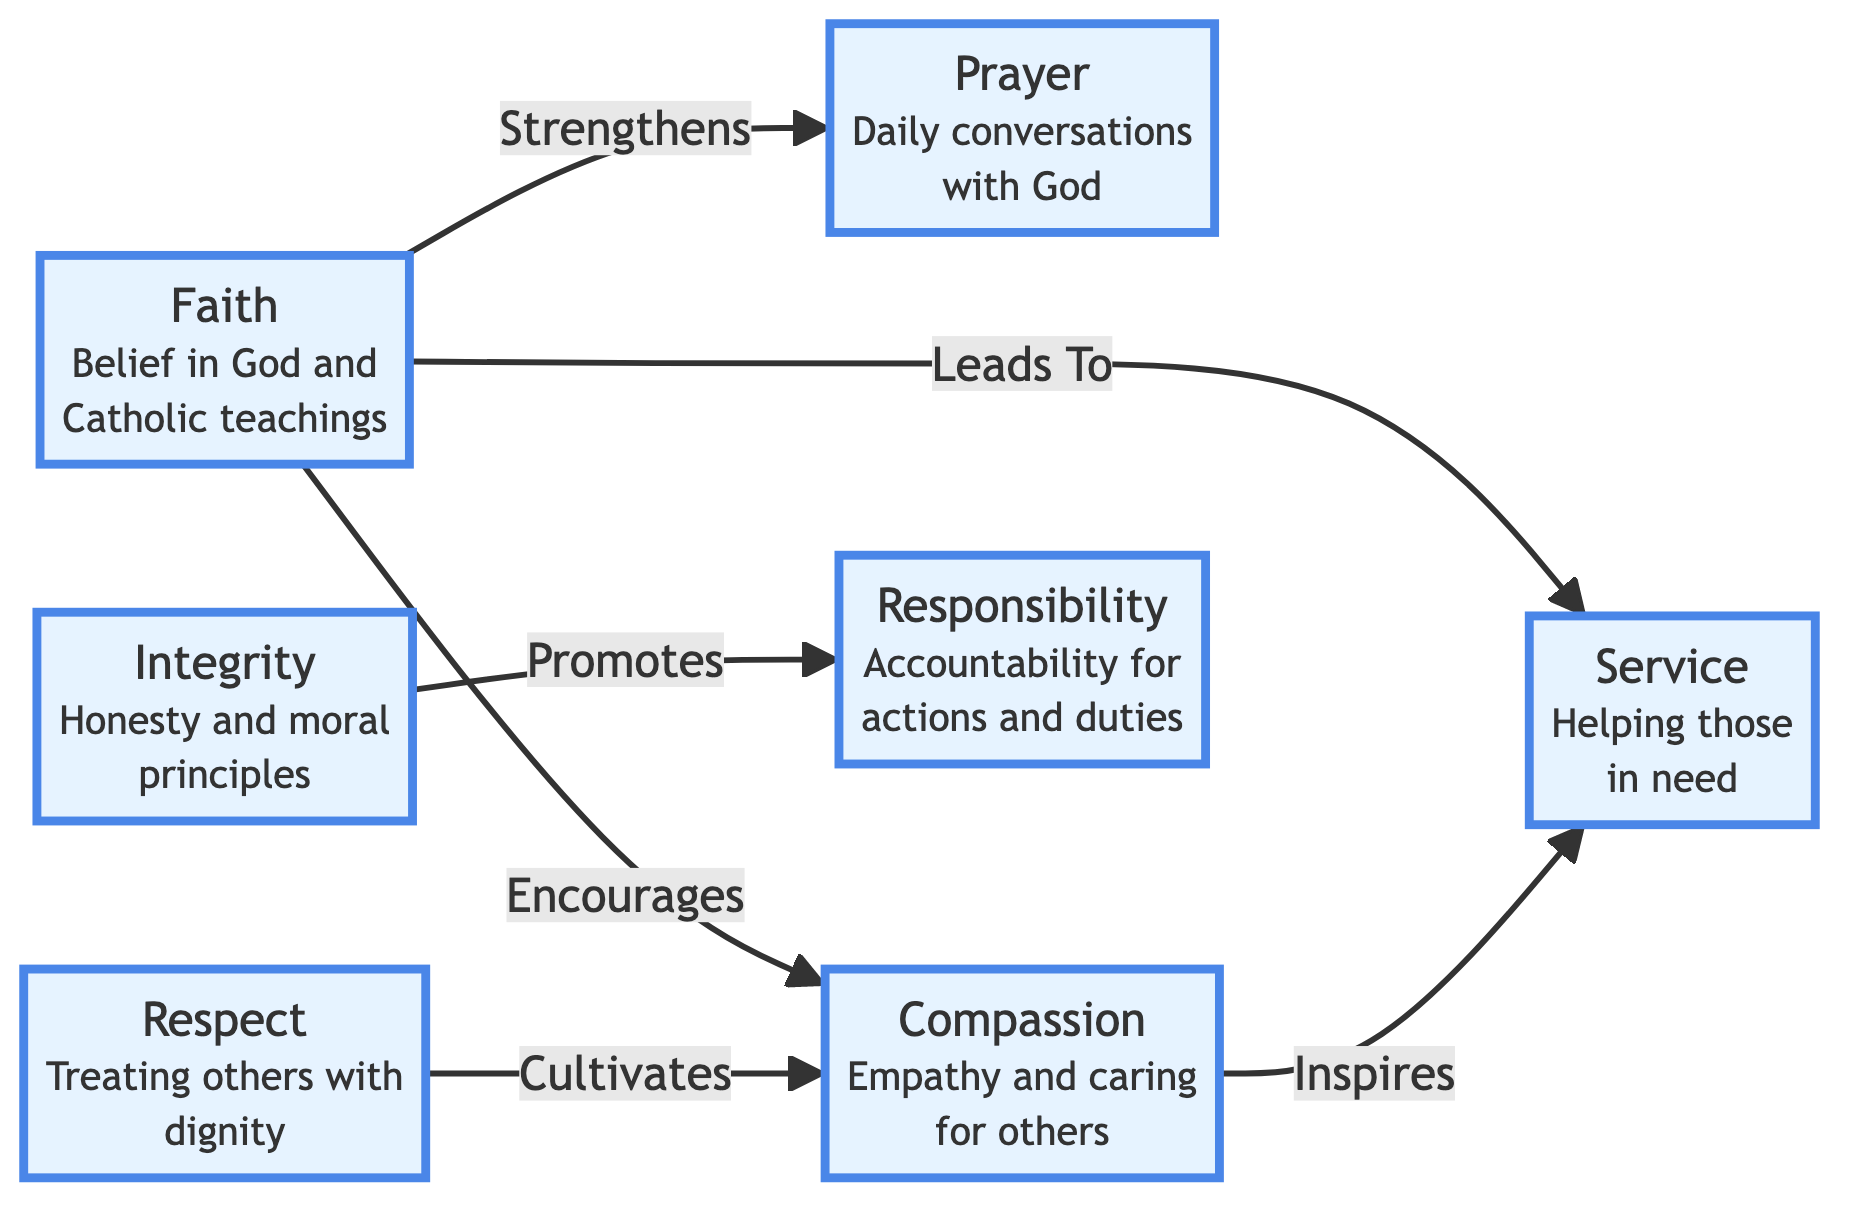What is the label of the node that represents "Empathy and caring for others"? The node labeled "Compassion" explicitly represents "Empathy and caring for others."
Answer: Compassion How many nodes are present in the diagram? By counting all the individual entries in the nodes list, there are a total of 7 unique nodes.
Answer: 7 Which virtue encourages compassion? The diagram indicates that "Faith" encourages the virtue of "Compassion."
Answer: Faith What relationship does "Integrity" have with "Responsibility"? The label on the edge connecting "Integrity" to "Responsibility" indicates that "Integrity" promotes "Responsibility."
Answer: Promotes Which virtue is strengthened by faith? According to the directed edge from "Faith" to "Prayer," faith strengthens prayer.
Answer: Prayer What virtue does respect cultivate? The edge from "Respect" to "Compassion" shows that respect cultivates compassion.
Answer: Compassion Identify the virtue that directly leads to service. The edge labeled "Leads To" connects "Faith" directly to "Service," indicating that faith leads to service.
Answer: Faith How does compassion relate to service? The diagram shows that compassion inspires service, as indicated by the edge linking the two nodes.
Answer: Inspires What is the total number of edges in the diagram? By counting all the connections listed in the edges, there are 6 edges present.
Answer: 6 